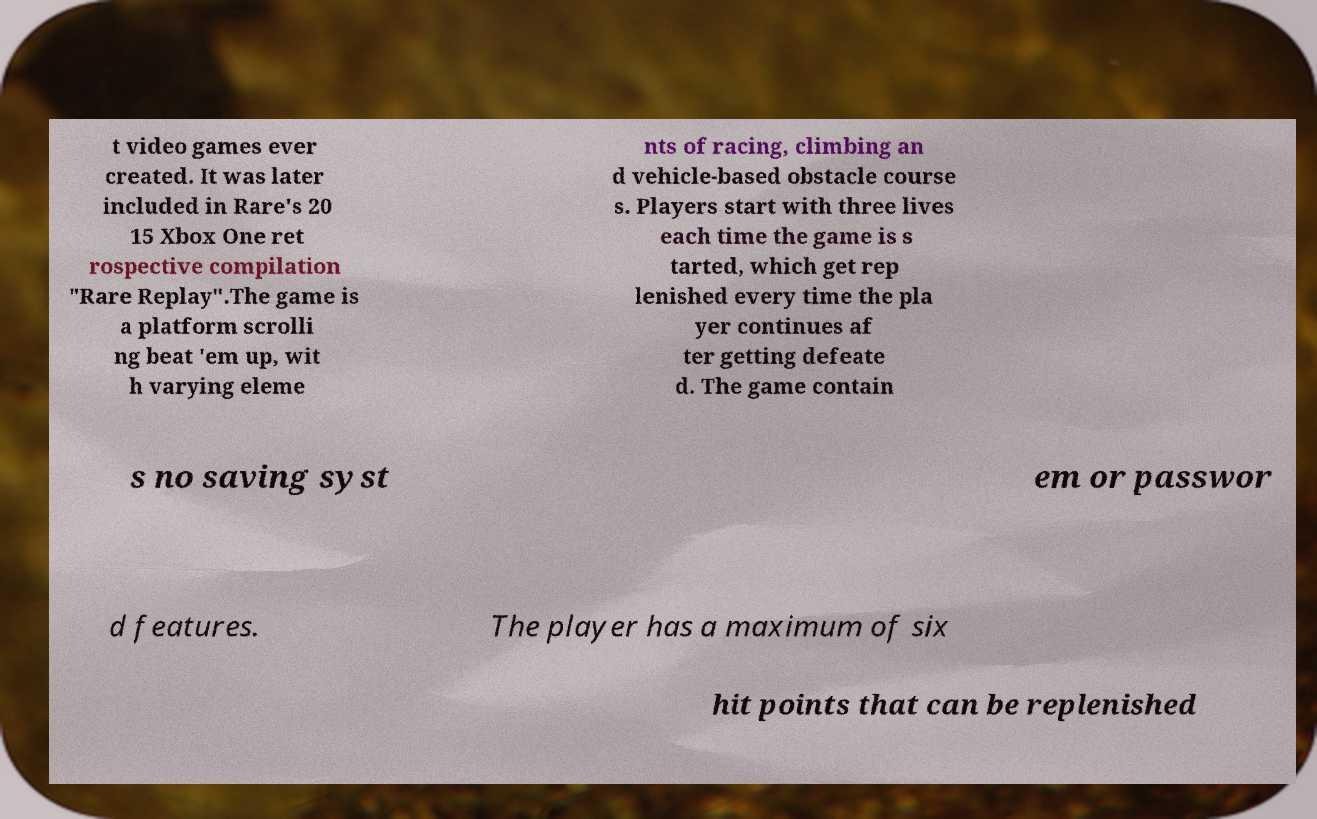Could you extract and type out the text from this image? t video games ever created. It was later included in Rare's 20 15 Xbox One ret rospective compilation "Rare Replay".The game is a platform scrolli ng beat 'em up, wit h varying eleme nts of racing, climbing an d vehicle-based obstacle course s. Players start with three lives each time the game is s tarted, which get rep lenished every time the pla yer continues af ter getting defeate d. The game contain s no saving syst em or passwor d features. The player has a maximum of six hit points that can be replenished 